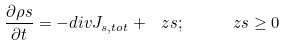Convert formula to latex. <formula><loc_0><loc_0><loc_500><loc_500>\frac { \partial \rho s } { \partial t } = - d i v { J } _ { s , t o t } + \ z s ; \quad \ z s \geq 0</formula> 